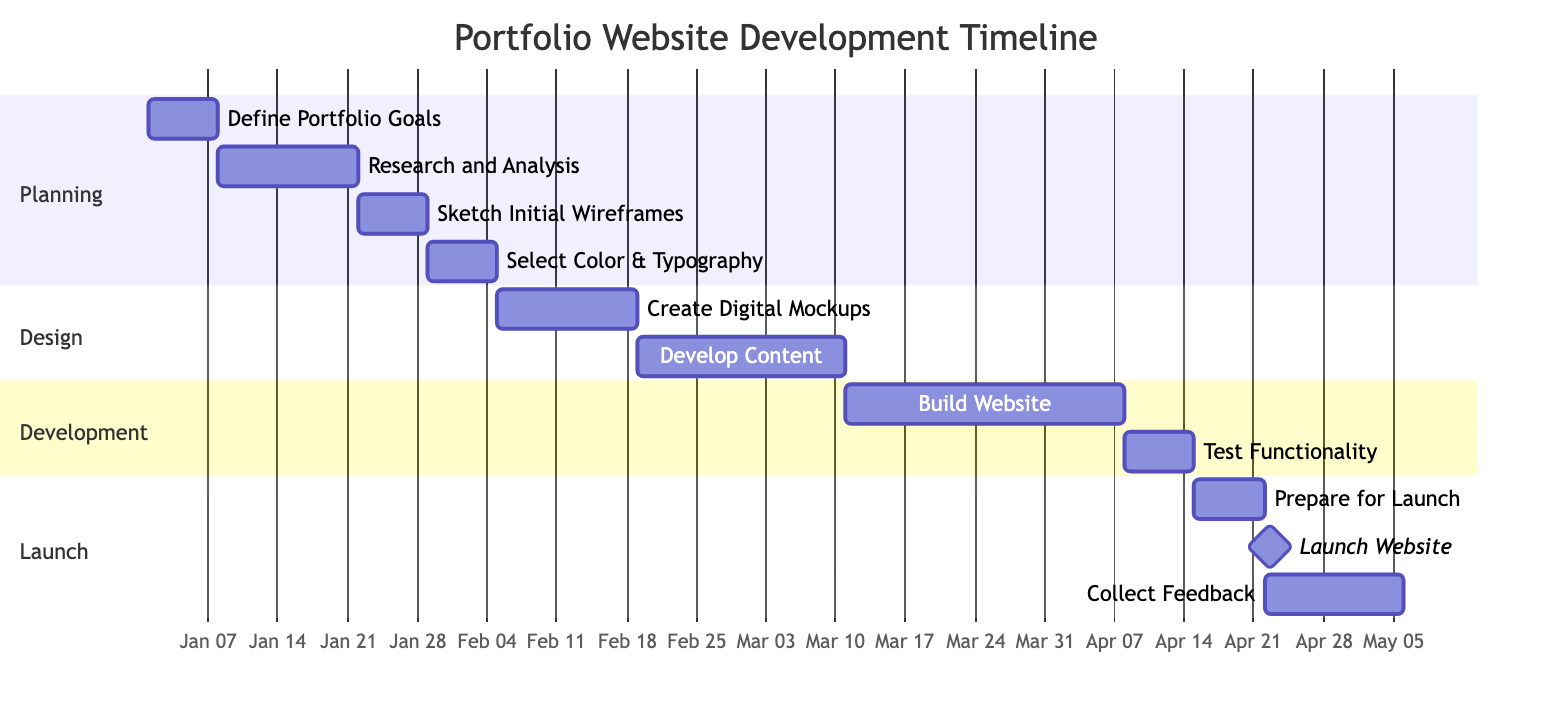What is the duration of the "Research and Analysis" task? The duration of the "Research and Analysis" task is indicated in the diagram, where it shows that this task lasts for 2 weeks starting from January 8, 2024, and ending on January 21, 2024.
Answer: 2 weeks When does the "Sketch Initial Wireframes" task start? According to the Gantt chart, the "Sketch Initial Wireframes" task begins immediately after the "Research and Analysis" task, which ends on January 21, 2024. Therefore, this task starts on January 22, 2024.
Answer: January 22, 2024 How many weeks are allocated for "Develop Content for Portfolio Entries"? The Gantt chart indicates that the task "Develop Content for Portfolio Entries" spans 3 weeks, beginning on February 19, 2024, and concluding on March 10, 2024.
Answer: 3 weeks Which task immediately follows the "Test Website Functionality and Usability"? The diagram shows that "Prepare for Launch" follows directly after "Test Website Functionality and Usability," which ends on April 14, 2024. Therefore, "Prepare for Launch" starts on April 15, 2024.
Answer: Prepare for Launch How many total milestones are present in the diagram? The diagram includes one milestone, which is the "Launch Portfolio Website" task that has a specific duration of 1 day after the preparation stage. This is the only milestone indicated.
Answer: 1 What is the total duration of the "Design" phase? The "Design" phase consists of two tasks: "Create Digital Mockups" for 2 weeks and "Develop Content" for 3 weeks. Therefore, the total duration for the "Design" phase is the sum of these two durations: 2 weeks + 3 weeks = 5 weeks.
Answer: 5 weeks Which task is scheduled to take place immediately after "Build Website Using HTML/CSS/JS"? In the Gantt chart, "Test Website Functionality and Usability" follows immediately after "Build Website Using HTML/CSS/JS," which is scheduled for four weeks. Hence, testing starts right after building is completed.
Answer: Test Website Functionality and Usability What is the starting date of the "Launch Portfolio Website"? The diagram specifies that the "Launch Portfolio Website" takes place on April 22, 2024, as indicated by the milestone marker following the "Prepare for Launch" task.
Answer: April 22, 2024 